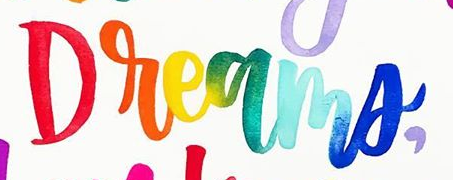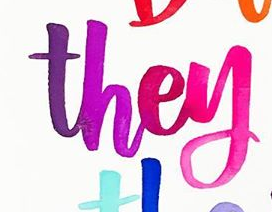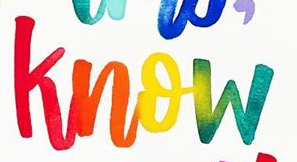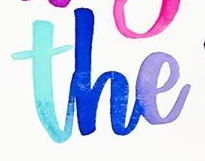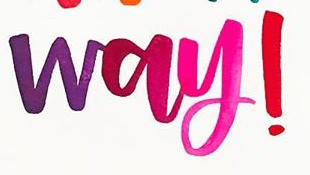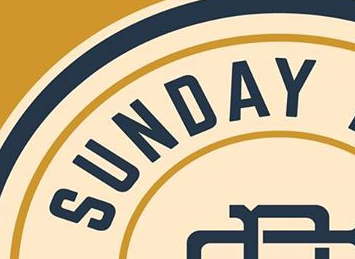Transcribe the words shown in these images in order, separated by a semicolon. Dreams,; they; know; the; way!; SUNDAY 